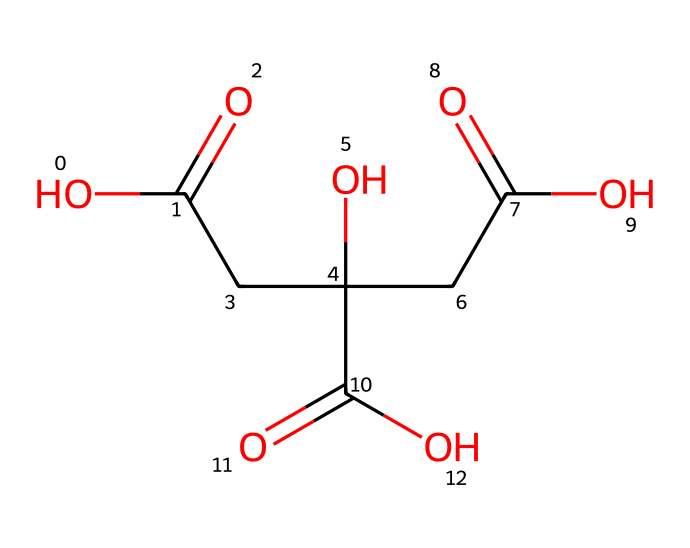What is the name of this chemical? The chemical is known as citric acid, which is commonly found in citrus fruits. The structure consists of three carboxylic acid groups and one hydroxyl group that characterize citric acid.
Answer: citric acid How many carboxylic acid groups are present in this structure? By examining the structure, we can identify three distinct carboxylic acid groups (COOH). Each carboxylic group contributes to the acidic nature of the compound.
Answer: three What is the molecular formula of this chemical? To derive the molecular formula, we identify the elements and their counts from the structure: for citric acid, they are C6, H8, and O7. Thus, the molecular formula becomes C6H8O7.
Answer: C6H8O7 What is the pH range typically associated with citric acid? Citric acid is a weak acid, and its pH in solution generally ranges from around 2 to 3, depending on the concentration. This low pH indicates its acidic characteristics.
Answer: 2 to 3 What role does citric acid play in fruits' flavor? Citric acid contributes to the tart and sour flavor in many fruits, particularly citrus varieties. It enhances the overall taste and is a natural preservative as well.
Answer: tart and sour Is citric acid used as a food preservative? Yes, citric acid is commonly used as a food preservative due to its ability to inhibit microbial growth and maintain flavor stability in various food products.
Answer: yes 